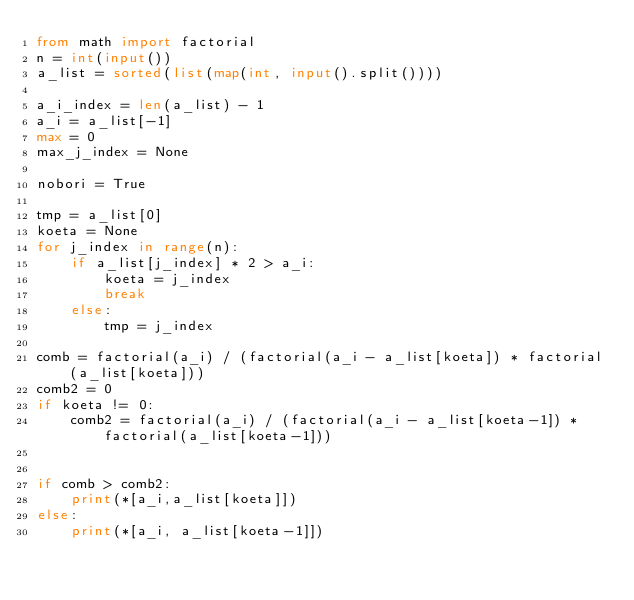<code> <loc_0><loc_0><loc_500><loc_500><_Python_>from math import factorial
n = int(input())
a_list = sorted(list(map(int, input().split())))

a_i_index = len(a_list) - 1
a_i = a_list[-1]
max = 0
max_j_index = None

nobori = True

tmp = a_list[0]
koeta = None
for j_index in range(n):
    if a_list[j_index] * 2 > a_i:
        koeta = j_index
        break
    else:
        tmp = j_index

comb = factorial(a_i) / (factorial(a_i - a_list[koeta]) * factorial(a_list[koeta]))
comb2 = 0
if koeta != 0:
    comb2 = factorial(a_i) / (factorial(a_i - a_list[koeta-1]) * factorial(a_list[koeta-1]))


if comb > comb2:
    print(*[a_i,a_list[koeta]])
else:
    print(*[a_i, a_list[koeta-1]])

</code> 